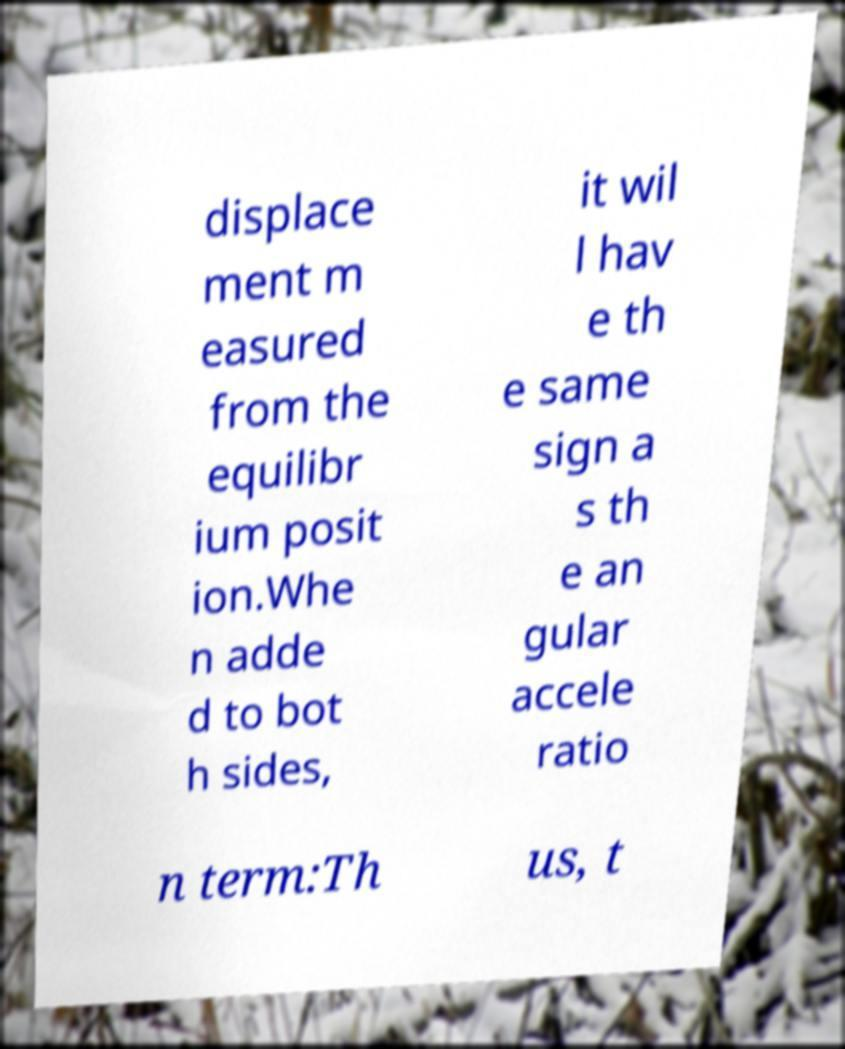Can you accurately transcribe the text from the provided image for me? displace ment m easured from the equilibr ium posit ion.Whe n adde d to bot h sides, it wil l hav e th e same sign a s th e an gular accele ratio n term:Th us, t 